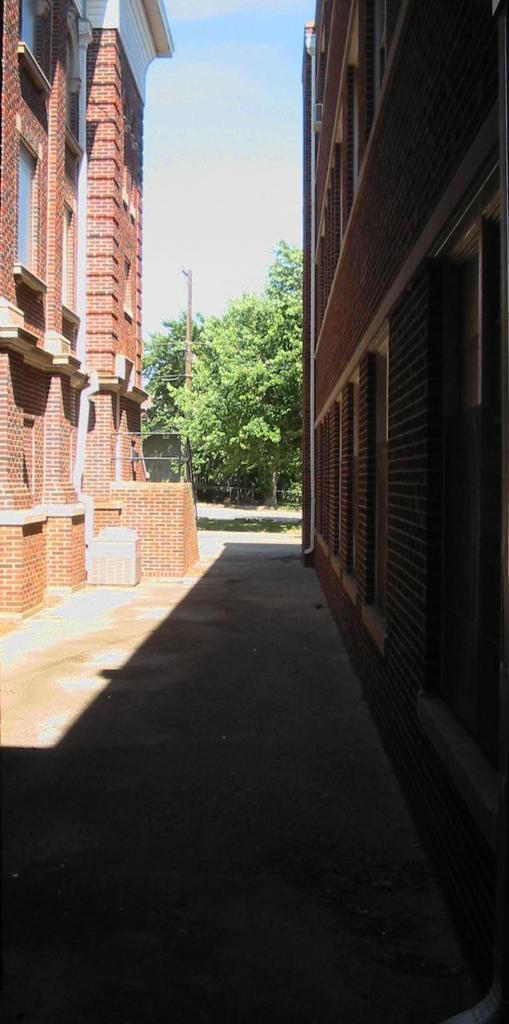How would you summarize this image in a sentence or two? In this image we can see buildings with windows and railing. In the background, we can see a group of trees and the sky. 